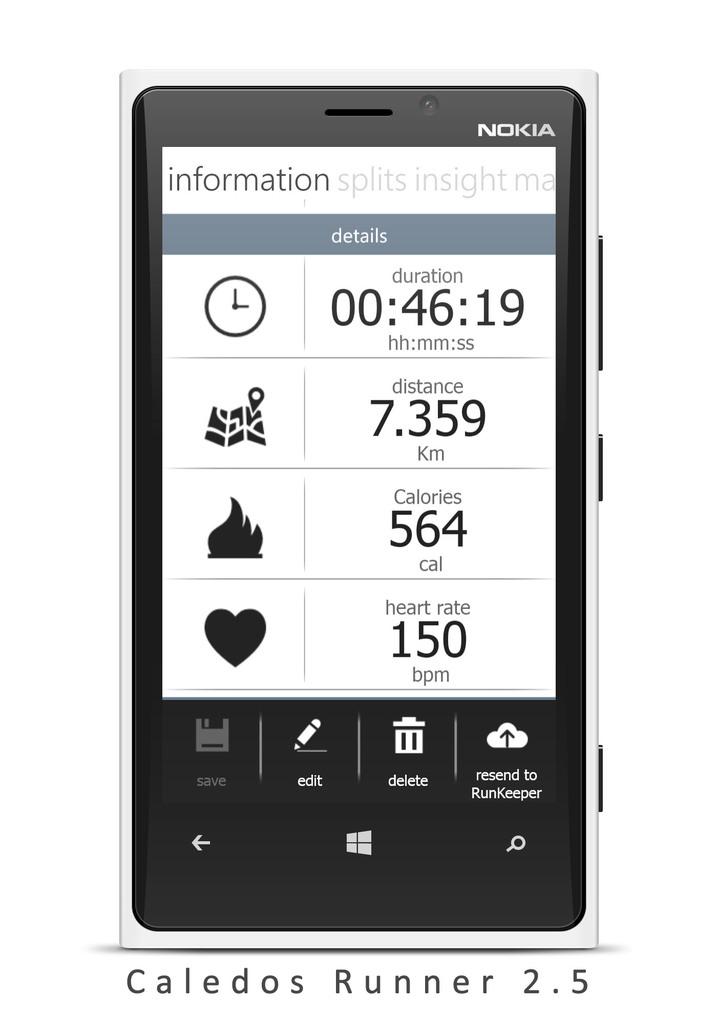What brand of phone is this?
Provide a succinct answer. Nokia. 